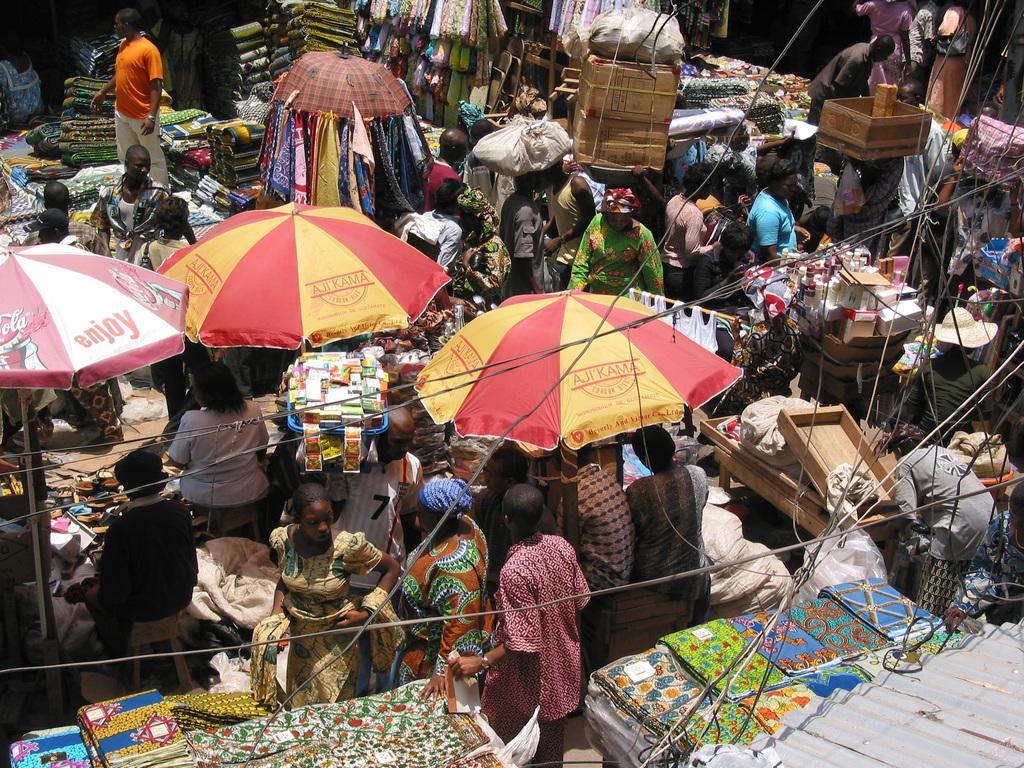What type of location is depicted in the image? There is a market in the image. What items can be seen for sale in the market? There are stoles visible in the market. Are there any people present in the image? Yes, there are people present in the market. What type of fruit is being taught in the image? There is no fruit or teaching activity present in the image; it depicts a market with stoles for sale. 